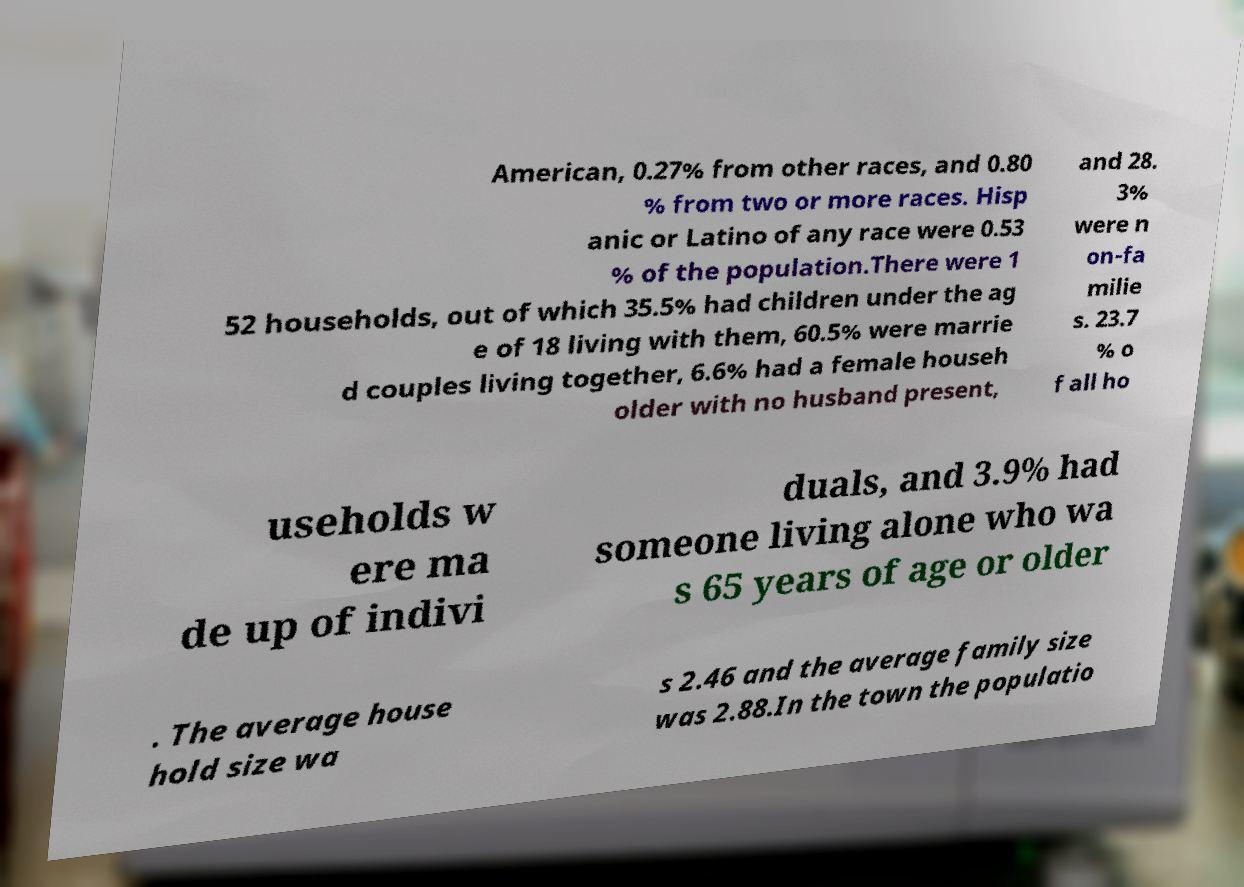Please identify and transcribe the text found in this image. American, 0.27% from other races, and 0.80 % from two or more races. Hisp anic or Latino of any race were 0.53 % of the population.There were 1 52 households, out of which 35.5% had children under the ag e of 18 living with them, 60.5% were marrie d couples living together, 6.6% had a female househ older with no husband present, and 28. 3% were n on-fa milie s. 23.7 % o f all ho useholds w ere ma de up of indivi duals, and 3.9% had someone living alone who wa s 65 years of age or older . The average house hold size wa s 2.46 and the average family size was 2.88.In the town the populatio 